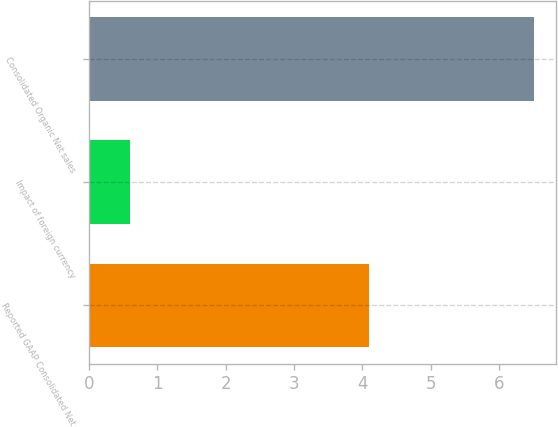Convert chart to OTSL. <chart><loc_0><loc_0><loc_500><loc_500><bar_chart><fcel>Reported GAAP Consolidated Net<fcel>Impact of foreign currency<fcel>Consolidated Organic Net sales<nl><fcel>4.1<fcel>0.6<fcel>6.5<nl></chart> 